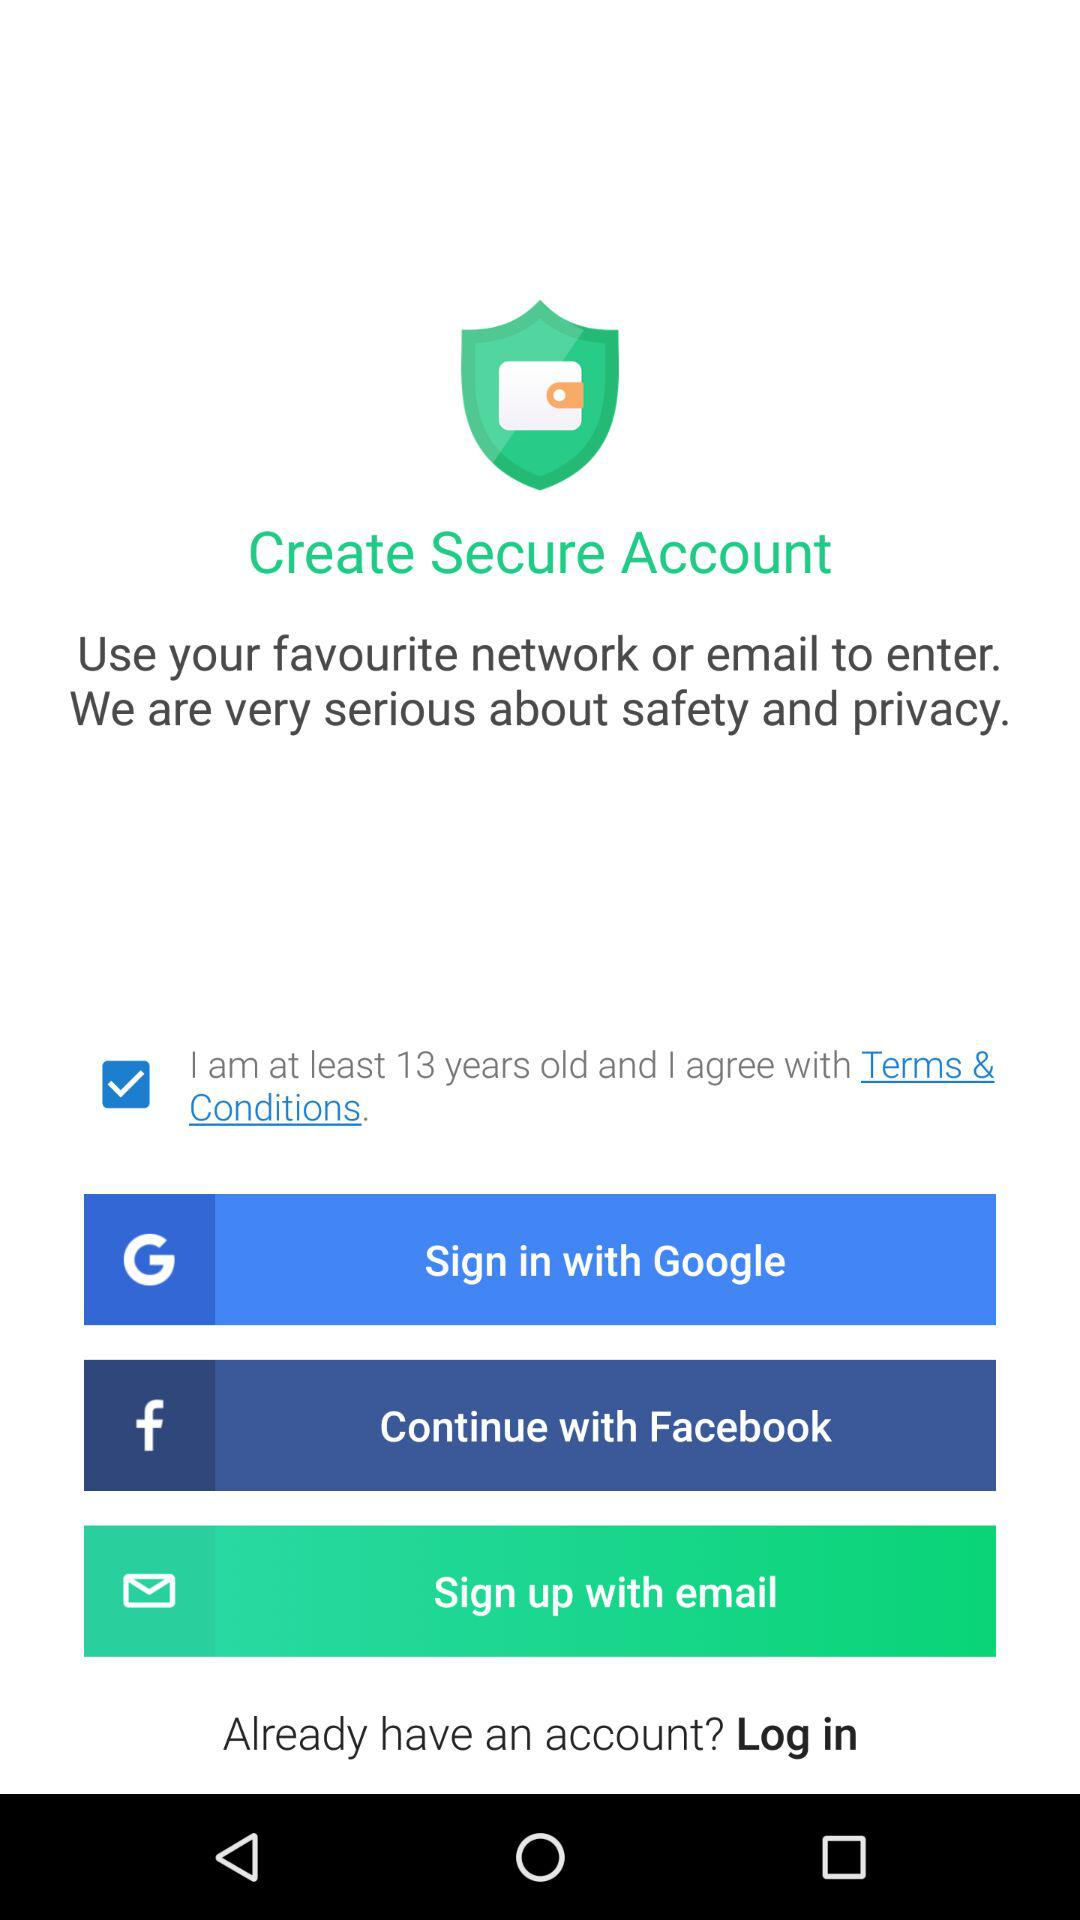What is the status of the option that includes acceptance to the "Terms & Conditions"? The status is "on". 